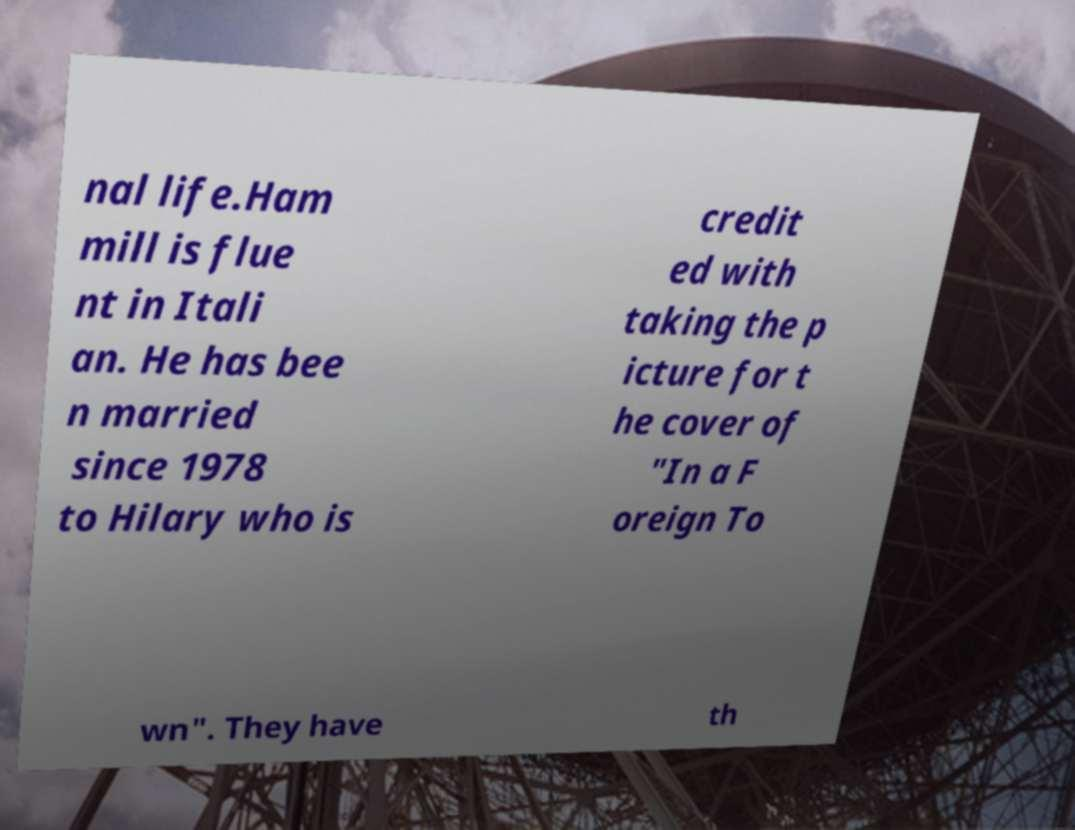There's text embedded in this image that I need extracted. Can you transcribe it verbatim? nal life.Ham mill is flue nt in Itali an. He has bee n married since 1978 to Hilary who is credit ed with taking the p icture for t he cover of "In a F oreign To wn". They have th 